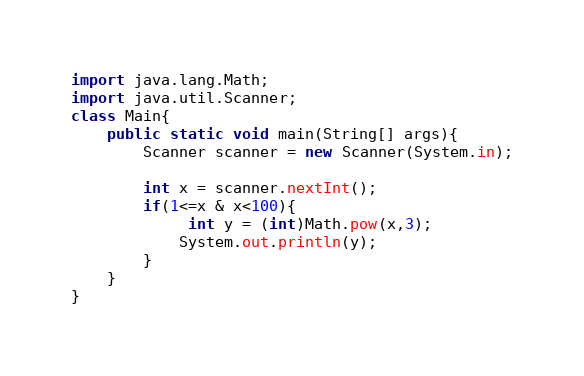<code> <loc_0><loc_0><loc_500><loc_500><_Java_>import java.lang.Math;
import java.util.Scanner;
class Main{
	public static void main(String[] args){
		Scanner scanner = new Scanner(System.in);
		
		int x = scanner.nextInt();
		if(1<=x & x<100){
			 int y = (int)Math.pow(x,3);
			System.out.println(y);
		}
	}
}

</code> 